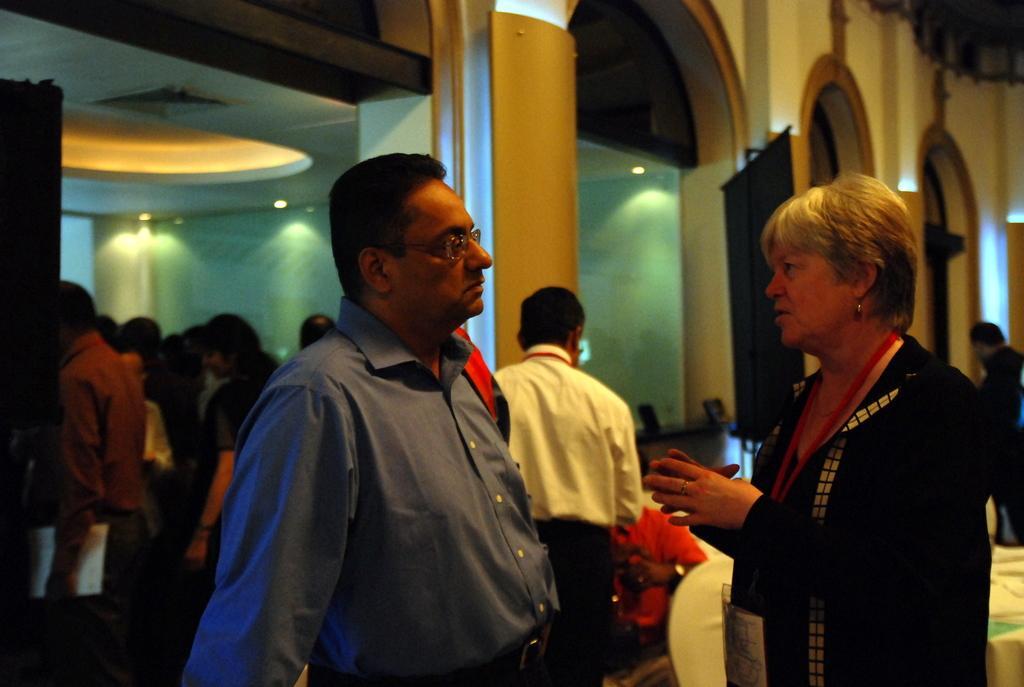Can you describe this image briefly? In this image we can see a few people, one of them is sitting on the chair, also we can see the boards, pillars, also we can see the lights, and the wall. 